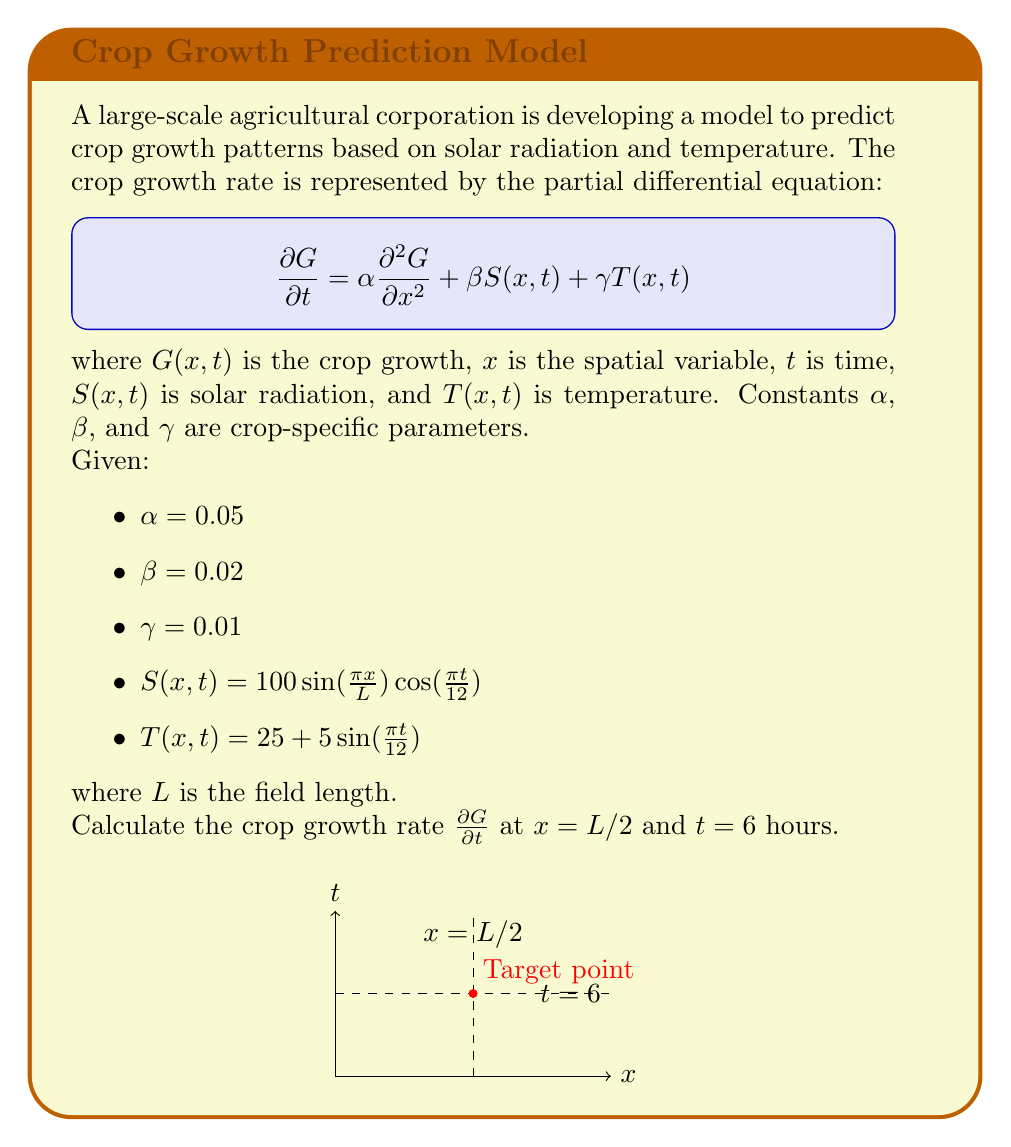What is the answer to this math problem? Let's approach this step-by-step:

1) We need to evaluate the terms in the PDE at $x = L/2$ and $t = 6$:

2) For the solar radiation term:
   $$S(L/2, 6) = 100 \sin(\frac{\pi L/2}{L}) \cos(\frac{\pi 6}{12})$$
   $$= 100 \sin(\frac{\pi}{2}) \cos(\frac{\pi}{2}) = 100 \cdot 1 \cdot 0 = 0$$

3) For the temperature term:
   $$T(L/2, 6) = 25 + 5 \sin(\frac{\pi 6}{12}) = 25 + 5 \sin(\frac{\pi}{2}) = 25 + 5 = 30$$

4) We don't have enough information to calculate $\frac{\partial^2 G}{\partial x^2}$ directly, so we'll represent it as a variable $k$.

5) Now, let's substitute these values into the PDE:

   $$\frac{\partial G}{\partial t} = \alpha \frac{\partial^2 G}{\partial x^2} + \beta S(x,t) + \gamma T(x,t)$$
   $$\frac{\partial G}{\partial t} = 0.05k + 0.02 \cdot 0 + 0.01 \cdot 30$$
   $$\frac{\partial G}{\partial t} = 0.05k + 0.3$$

6) This is our final expression for the crop growth rate at the specified point.
Answer: $\frac{\partial G}{\partial t} = 0.05k + 0.3$ 